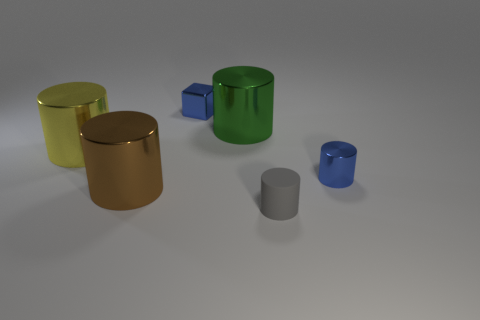There is a tiny gray thing that is the same shape as the large green metallic object; what material is it?
Offer a terse response. Rubber. The yellow shiny cylinder is what size?
Ensure brevity in your answer.  Large. There is a large brown thing that is the same material as the big green thing; what is its shape?
Your response must be concise. Cylinder. Do the tiny blue metallic thing in front of the big yellow metallic object and the large brown thing have the same shape?
Your answer should be very brief. Yes. What number of things are either yellow metallic cylinders or brown cylinders?
Offer a very short reply. 2. There is a large object that is both to the right of the yellow thing and to the left of the small metal block; what material is it?
Your answer should be compact. Metal. Does the metallic block have the same size as the green cylinder?
Your answer should be very brief. No. What size is the blue shiny thing that is right of the tiny blue thing behind the large yellow thing?
Provide a succinct answer. Small. How many big shiny things are both left of the big green cylinder and behind the big yellow metallic cylinder?
Offer a terse response. 0. Is there a cube that is to the right of the tiny rubber thing that is in front of the blue thing to the left of the tiny rubber object?
Your answer should be compact. No. 